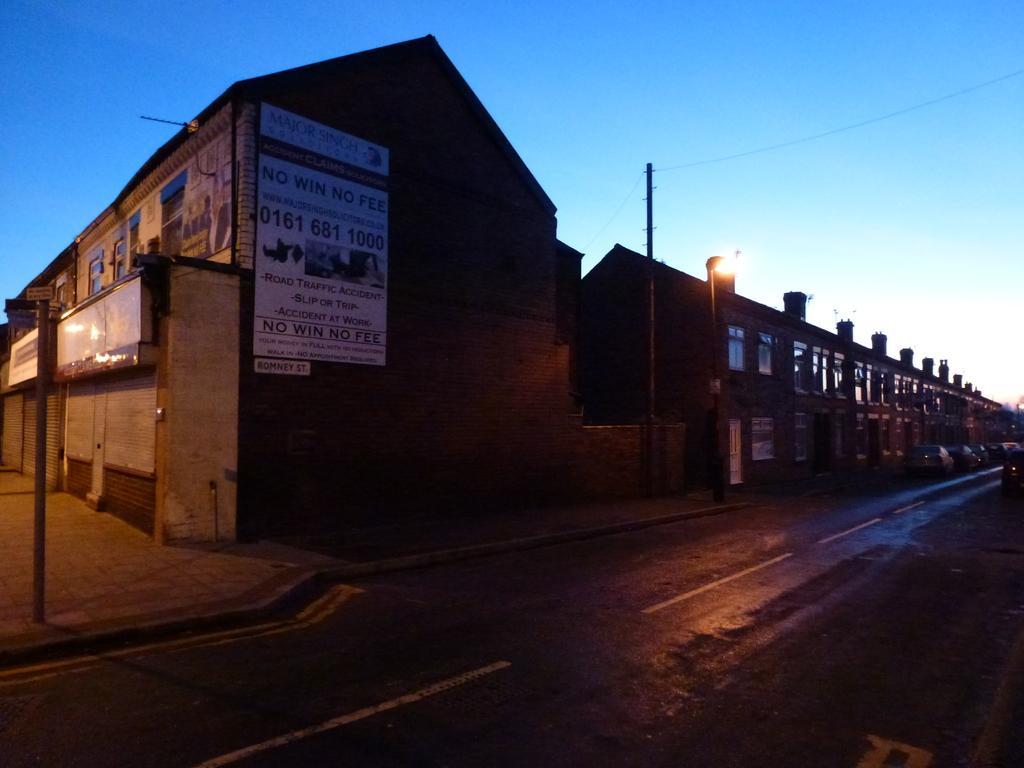How would you summarize this image in a sentence or two? This is an image clicked in the dark. At the bottom there is a road. In the middle of the image there are few buildings. Beside the road there are few light poles. On the left side there is a board attached to the wall of a building. At the top of the image I can see the sky. 